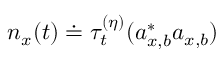Convert formula to latex. <formula><loc_0><loc_0><loc_500><loc_500>n _ { x } ( t ) \doteq \tau _ { t } ^ { ( \eta ) } ( a _ { x , b } ^ { \ast } a _ { x , b } )</formula> 